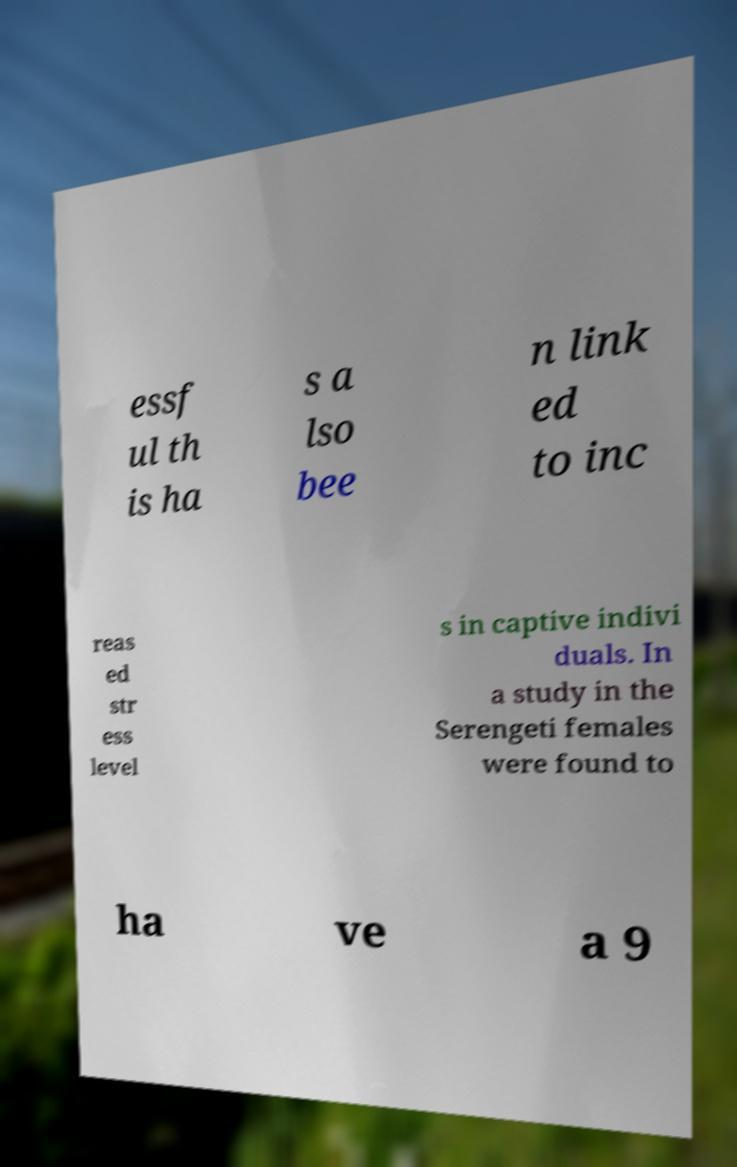What messages or text are displayed in this image? I need them in a readable, typed format. essf ul th is ha s a lso bee n link ed to inc reas ed str ess level s in captive indivi duals. In a study in the Serengeti females were found to ha ve a 9 